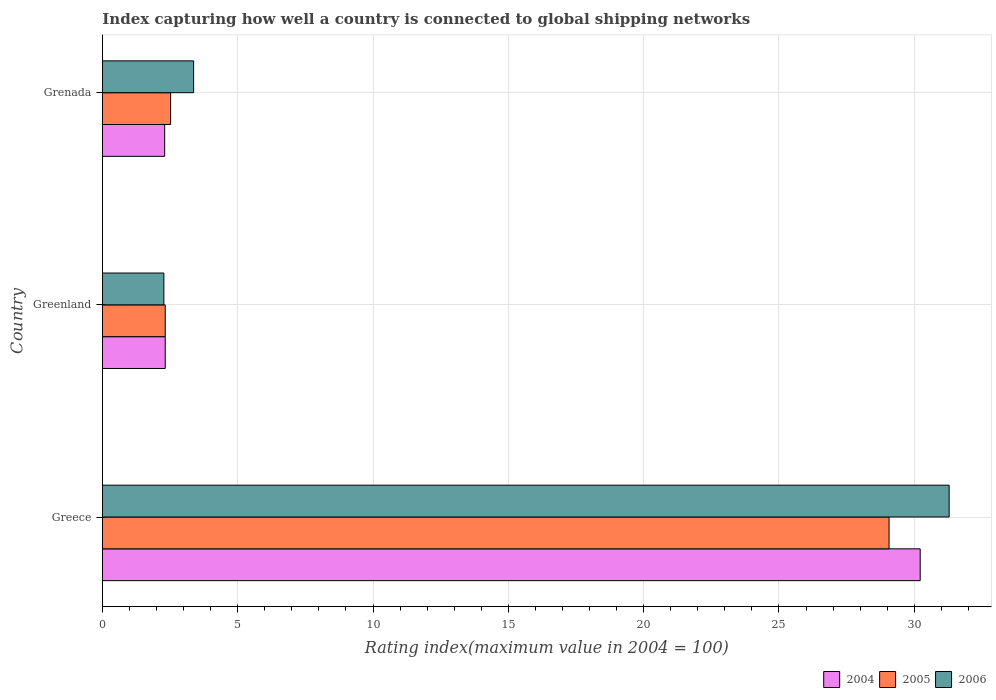How many different coloured bars are there?
Offer a very short reply. 3. Are the number of bars on each tick of the Y-axis equal?
Offer a terse response. Yes. How many bars are there on the 3rd tick from the top?
Keep it short and to the point. 3. How many bars are there on the 3rd tick from the bottom?
Offer a terse response. 3. What is the label of the 1st group of bars from the top?
Ensure brevity in your answer.  Grenada. In how many cases, is the number of bars for a given country not equal to the number of legend labels?
Your answer should be compact. 0. What is the rating index in 2004 in Grenada?
Your answer should be compact. 2.3. Across all countries, what is the maximum rating index in 2005?
Make the answer very short. 29.07. Across all countries, what is the minimum rating index in 2005?
Your answer should be very brief. 2.32. In which country was the rating index in 2005 minimum?
Keep it short and to the point. Greenland. What is the total rating index in 2006 in the graph?
Offer a terse response. 36.93. What is the difference between the rating index in 2004 in Greece and that in Greenland?
Your response must be concise. 27.9. What is the difference between the rating index in 2004 in Greece and the rating index in 2005 in Grenada?
Ensure brevity in your answer.  27.7. What is the average rating index in 2004 per country?
Give a very brief answer. 11.61. What is the difference between the rating index in 2005 and rating index in 2006 in Greece?
Make the answer very short. -2.22. In how many countries, is the rating index in 2004 greater than 3 ?
Your answer should be compact. 1. What is the ratio of the rating index in 2005 in Greece to that in Grenada?
Your response must be concise. 11.54. Is the rating index in 2004 in Greenland less than that in Grenada?
Ensure brevity in your answer.  No. Is the difference between the rating index in 2005 in Greece and Grenada greater than the difference between the rating index in 2006 in Greece and Grenada?
Give a very brief answer. No. What is the difference between the highest and the second highest rating index in 2006?
Provide a short and direct response. 27.92. What is the difference between the highest and the lowest rating index in 2005?
Your response must be concise. 26.75. Is the sum of the rating index in 2006 in Greece and Grenada greater than the maximum rating index in 2004 across all countries?
Make the answer very short. Yes. What does the 1st bar from the top in Greenland represents?
Give a very brief answer. 2006. What does the 2nd bar from the bottom in Grenada represents?
Ensure brevity in your answer.  2005. Is it the case that in every country, the sum of the rating index in 2004 and rating index in 2005 is greater than the rating index in 2006?
Your answer should be very brief. Yes. How many bars are there?
Provide a short and direct response. 9. Are all the bars in the graph horizontal?
Your response must be concise. Yes. How many countries are there in the graph?
Your answer should be compact. 3. What is the difference between two consecutive major ticks on the X-axis?
Keep it short and to the point. 5. Are the values on the major ticks of X-axis written in scientific E-notation?
Your response must be concise. No. Does the graph contain any zero values?
Offer a terse response. No. How are the legend labels stacked?
Your answer should be very brief. Horizontal. What is the title of the graph?
Ensure brevity in your answer.  Index capturing how well a country is connected to global shipping networks. Does "2013" appear as one of the legend labels in the graph?
Ensure brevity in your answer.  No. What is the label or title of the X-axis?
Give a very brief answer. Rating index(maximum value in 2004 = 100). What is the label or title of the Y-axis?
Your answer should be compact. Country. What is the Rating index(maximum value in 2004 = 100) of 2004 in Greece?
Provide a succinct answer. 30.22. What is the Rating index(maximum value in 2004 = 100) in 2005 in Greece?
Keep it short and to the point. 29.07. What is the Rating index(maximum value in 2004 = 100) of 2006 in Greece?
Your response must be concise. 31.29. What is the Rating index(maximum value in 2004 = 100) in 2004 in Greenland?
Your answer should be compact. 2.32. What is the Rating index(maximum value in 2004 = 100) in 2005 in Greenland?
Your response must be concise. 2.32. What is the Rating index(maximum value in 2004 = 100) in 2006 in Greenland?
Offer a terse response. 2.27. What is the Rating index(maximum value in 2004 = 100) of 2004 in Grenada?
Offer a terse response. 2.3. What is the Rating index(maximum value in 2004 = 100) of 2005 in Grenada?
Ensure brevity in your answer.  2.52. What is the Rating index(maximum value in 2004 = 100) of 2006 in Grenada?
Your response must be concise. 3.37. Across all countries, what is the maximum Rating index(maximum value in 2004 = 100) in 2004?
Ensure brevity in your answer.  30.22. Across all countries, what is the maximum Rating index(maximum value in 2004 = 100) of 2005?
Give a very brief answer. 29.07. Across all countries, what is the maximum Rating index(maximum value in 2004 = 100) in 2006?
Provide a succinct answer. 31.29. Across all countries, what is the minimum Rating index(maximum value in 2004 = 100) of 2005?
Ensure brevity in your answer.  2.32. Across all countries, what is the minimum Rating index(maximum value in 2004 = 100) in 2006?
Offer a very short reply. 2.27. What is the total Rating index(maximum value in 2004 = 100) in 2004 in the graph?
Offer a terse response. 34.84. What is the total Rating index(maximum value in 2004 = 100) in 2005 in the graph?
Give a very brief answer. 33.91. What is the total Rating index(maximum value in 2004 = 100) of 2006 in the graph?
Ensure brevity in your answer.  36.93. What is the difference between the Rating index(maximum value in 2004 = 100) in 2004 in Greece and that in Greenland?
Give a very brief answer. 27.9. What is the difference between the Rating index(maximum value in 2004 = 100) in 2005 in Greece and that in Greenland?
Your answer should be compact. 26.75. What is the difference between the Rating index(maximum value in 2004 = 100) of 2006 in Greece and that in Greenland?
Provide a short and direct response. 29.02. What is the difference between the Rating index(maximum value in 2004 = 100) in 2004 in Greece and that in Grenada?
Keep it short and to the point. 27.92. What is the difference between the Rating index(maximum value in 2004 = 100) in 2005 in Greece and that in Grenada?
Your response must be concise. 26.55. What is the difference between the Rating index(maximum value in 2004 = 100) in 2006 in Greece and that in Grenada?
Make the answer very short. 27.92. What is the difference between the Rating index(maximum value in 2004 = 100) of 2004 in Greenland and that in Grenada?
Your answer should be very brief. 0.02. What is the difference between the Rating index(maximum value in 2004 = 100) in 2005 in Greenland and that in Grenada?
Keep it short and to the point. -0.2. What is the difference between the Rating index(maximum value in 2004 = 100) in 2006 in Greenland and that in Grenada?
Provide a short and direct response. -1.1. What is the difference between the Rating index(maximum value in 2004 = 100) of 2004 in Greece and the Rating index(maximum value in 2004 = 100) of 2005 in Greenland?
Offer a very short reply. 27.9. What is the difference between the Rating index(maximum value in 2004 = 100) of 2004 in Greece and the Rating index(maximum value in 2004 = 100) of 2006 in Greenland?
Give a very brief answer. 27.95. What is the difference between the Rating index(maximum value in 2004 = 100) in 2005 in Greece and the Rating index(maximum value in 2004 = 100) in 2006 in Greenland?
Offer a very short reply. 26.8. What is the difference between the Rating index(maximum value in 2004 = 100) of 2004 in Greece and the Rating index(maximum value in 2004 = 100) of 2005 in Grenada?
Your answer should be compact. 27.7. What is the difference between the Rating index(maximum value in 2004 = 100) in 2004 in Greece and the Rating index(maximum value in 2004 = 100) in 2006 in Grenada?
Provide a short and direct response. 26.85. What is the difference between the Rating index(maximum value in 2004 = 100) of 2005 in Greece and the Rating index(maximum value in 2004 = 100) of 2006 in Grenada?
Offer a very short reply. 25.7. What is the difference between the Rating index(maximum value in 2004 = 100) in 2004 in Greenland and the Rating index(maximum value in 2004 = 100) in 2005 in Grenada?
Provide a short and direct response. -0.2. What is the difference between the Rating index(maximum value in 2004 = 100) in 2004 in Greenland and the Rating index(maximum value in 2004 = 100) in 2006 in Grenada?
Ensure brevity in your answer.  -1.05. What is the difference between the Rating index(maximum value in 2004 = 100) of 2005 in Greenland and the Rating index(maximum value in 2004 = 100) of 2006 in Grenada?
Your response must be concise. -1.05. What is the average Rating index(maximum value in 2004 = 100) of 2004 per country?
Keep it short and to the point. 11.61. What is the average Rating index(maximum value in 2004 = 100) of 2005 per country?
Your answer should be very brief. 11.3. What is the average Rating index(maximum value in 2004 = 100) of 2006 per country?
Provide a short and direct response. 12.31. What is the difference between the Rating index(maximum value in 2004 = 100) of 2004 and Rating index(maximum value in 2004 = 100) of 2005 in Greece?
Offer a very short reply. 1.15. What is the difference between the Rating index(maximum value in 2004 = 100) in 2004 and Rating index(maximum value in 2004 = 100) in 2006 in Greece?
Ensure brevity in your answer.  -1.07. What is the difference between the Rating index(maximum value in 2004 = 100) of 2005 and Rating index(maximum value in 2004 = 100) of 2006 in Greece?
Your answer should be compact. -2.22. What is the difference between the Rating index(maximum value in 2004 = 100) in 2004 and Rating index(maximum value in 2004 = 100) in 2005 in Greenland?
Keep it short and to the point. 0. What is the difference between the Rating index(maximum value in 2004 = 100) of 2005 and Rating index(maximum value in 2004 = 100) of 2006 in Greenland?
Keep it short and to the point. 0.05. What is the difference between the Rating index(maximum value in 2004 = 100) in 2004 and Rating index(maximum value in 2004 = 100) in 2005 in Grenada?
Your answer should be very brief. -0.22. What is the difference between the Rating index(maximum value in 2004 = 100) of 2004 and Rating index(maximum value in 2004 = 100) of 2006 in Grenada?
Keep it short and to the point. -1.07. What is the difference between the Rating index(maximum value in 2004 = 100) of 2005 and Rating index(maximum value in 2004 = 100) of 2006 in Grenada?
Your answer should be very brief. -0.85. What is the ratio of the Rating index(maximum value in 2004 = 100) in 2004 in Greece to that in Greenland?
Keep it short and to the point. 13.03. What is the ratio of the Rating index(maximum value in 2004 = 100) of 2005 in Greece to that in Greenland?
Offer a terse response. 12.53. What is the ratio of the Rating index(maximum value in 2004 = 100) of 2006 in Greece to that in Greenland?
Your answer should be very brief. 13.78. What is the ratio of the Rating index(maximum value in 2004 = 100) in 2004 in Greece to that in Grenada?
Your answer should be compact. 13.14. What is the ratio of the Rating index(maximum value in 2004 = 100) of 2005 in Greece to that in Grenada?
Your response must be concise. 11.54. What is the ratio of the Rating index(maximum value in 2004 = 100) in 2006 in Greece to that in Grenada?
Provide a short and direct response. 9.28. What is the ratio of the Rating index(maximum value in 2004 = 100) of 2004 in Greenland to that in Grenada?
Offer a very short reply. 1.01. What is the ratio of the Rating index(maximum value in 2004 = 100) in 2005 in Greenland to that in Grenada?
Provide a short and direct response. 0.92. What is the ratio of the Rating index(maximum value in 2004 = 100) in 2006 in Greenland to that in Grenada?
Offer a very short reply. 0.67. What is the difference between the highest and the second highest Rating index(maximum value in 2004 = 100) in 2004?
Give a very brief answer. 27.9. What is the difference between the highest and the second highest Rating index(maximum value in 2004 = 100) in 2005?
Ensure brevity in your answer.  26.55. What is the difference between the highest and the second highest Rating index(maximum value in 2004 = 100) of 2006?
Your response must be concise. 27.92. What is the difference between the highest and the lowest Rating index(maximum value in 2004 = 100) in 2004?
Offer a terse response. 27.92. What is the difference between the highest and the lowest Rating index(maximum value in 2004 = 100) of 2005?
Your response must be concise. 26.75. What is the difference between the highest and the lowest Rating index(maximum value in 2004 = 100) in 2006?
Offer a very short reply. 29.02. 